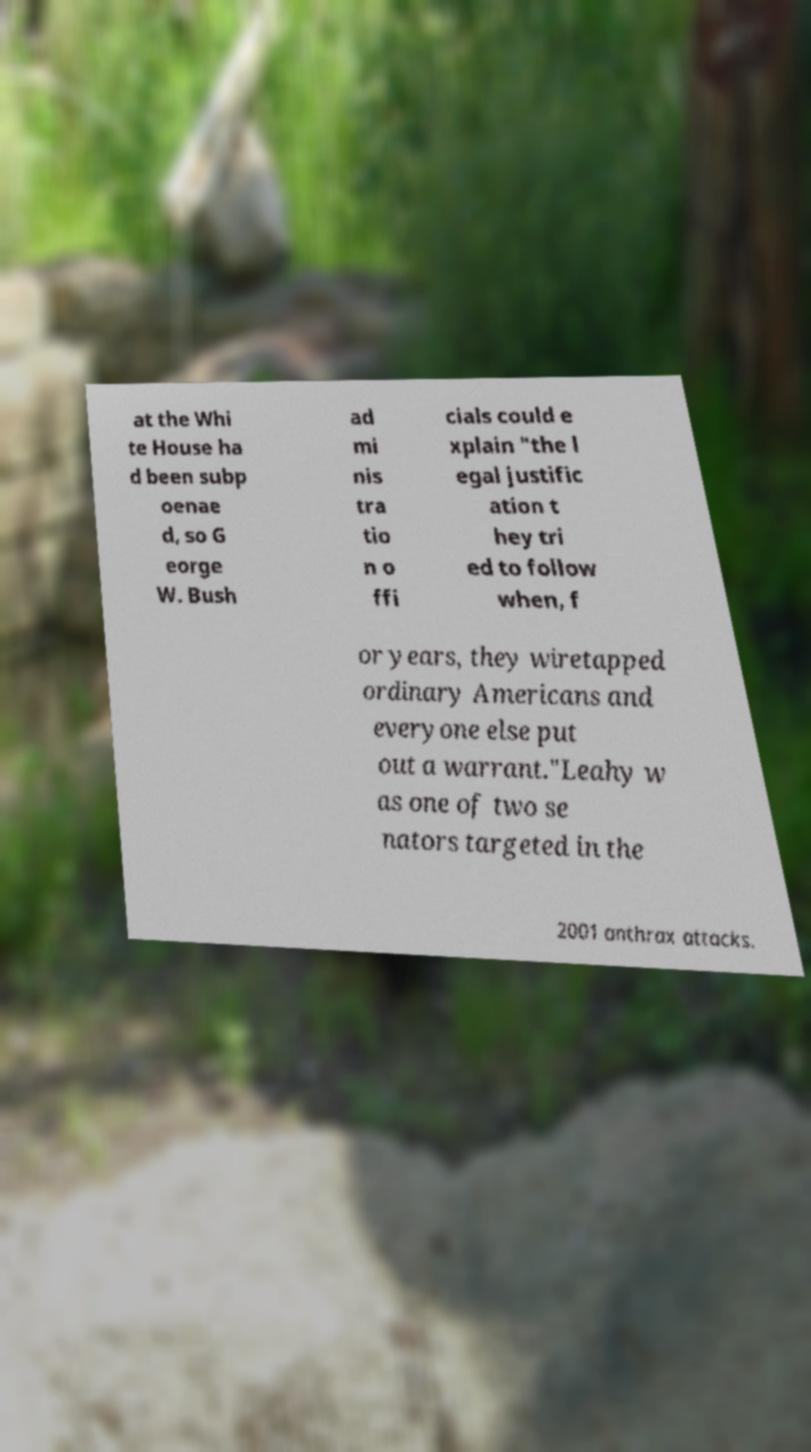Can you accurately transcribe the text from the provided image for me? at the Whi te House ha d been subp oenae d, so G eorge W. Bush ad mi nis tra tio n o ffi cials could e xplain "the l egal justific ation t hey tri ed to follow when, f or years, they wiretapped ordinary Americans and everyone else put out a warrant."Leahy w as one of two se nators targeted in the 2001 anthrax attacks. 